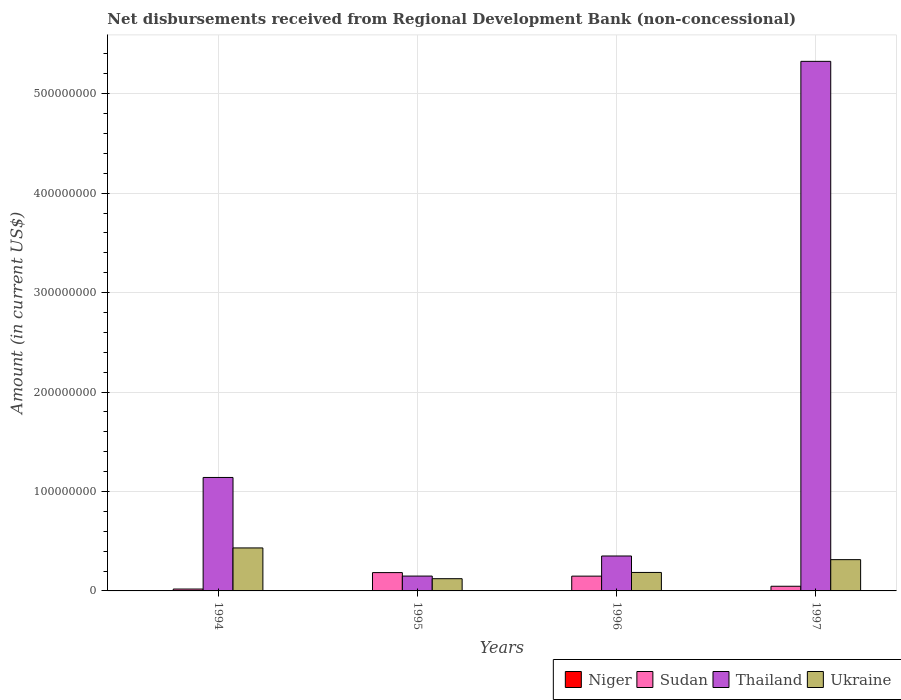How many different coloured bars are there?
Offer a very short reply. 3. Are the number of bars per tick equal to the number of legend labels?
Provide a succinct answer. No. Are the number of bars on each tick of the X-axis equal?
Offer a very short reply. Yes. In how many cases, is the number of bars for a given year not equal to the number of legend labels?
Your response must be concise. 4. What is the amount of disbursements received from Regional Development Bank in Sudan in 1995?
Provide a short and direct response. 1.84e+07. Across all years, what is the maximum amount of disbursements received from Regional Development Bank in Ukraine?
Your response must be concise. 4.32e+07. Across all years, what is the minimum amount of disbursements received from Regional Development Bank in Ukraine?
Provide a short and direct response. 1.23e+07. In which year was the amount of disbursements received from Regional Development Bank in Ukraine maximum?
Keep it short and to the point. 1994. What is the total amount of disbursements received from Regional Development Bank in Ukraine in the graph?
Offer a very short reply. 1.06e+08. What is the difference between the amount of disbursements received from Regional Development Bank in Thailand in 1995 and that in 1996?
Provide a succinct answer. -2.02e+07. What is the difference between the amount of disbursements received from Regional Development Bank in Sudan in 1996 and the amount of disbursements received from Regional Development Bank in Ukraine in 1994?
Make the answer very short. -2.84e+07. What is the average amount of disbursements received from Regional Development Bank in Sudan per year?
Ensure brevity in your answer.  9.97e+06. In the year 1997, what is the difference between the amount of disbursements received from Regional Development Bank in Sudan and amount of disbursements received from Regional Development Bank in Ukraine?
Provide a succinct answer. -2.68e+07. In how many years, is the amount of disbursements received from Regional Development Bank in Ukraine greater than 100000000 US$?
Your answer should be compact. 0. What is the ratio of the amount of disbursements received from Regional Development Bank in Sudan in 1994 to that in 1997?
Give a very brief answer. 0.4. Is the difference between the amount of disbursements received from Regional Development Bank in Sudan in 1995 and 1997 greater than the difference between the amount of disbursements received from Regional Development Bank in Ukraine in 1995 and 1997?
Your answer should be compact. Yes. What is the difference between the highest and the second highest amount of disbursements received from Regional Development Bank in Ukraine?
Your answer should be compact. 1.18e+07. What is the difference between the highest and the lowest amount of disbursements received from Regional Development Bank in Ukraine?
Offer a very short reply. 3.09e+07. How many bars are there?
Provide a short and direct response. 12. Are all the bars in the graph horizontal?
Offer a very short reply. No. What is the difference between two consecutive major ticks on the Y-axis?
Ensure brevity in your answer.  1.00e+08. Where does the legend appear in the graph?
Give a very brief answer. Bottom right. How many legend labels are there?
Provide a succinct answer. 4. How are the legend labels stacked?
Offer a terse response. Horizontal. What is the title of the graph?
Your answer should be very brief. Net disbursements received from Regional Development Bank (non-concessional). Does "Middle income" appear as one of the legend labels in the graph?
Give a very brief answer. No. What is the label or title of the X-axis?
Offer a very short reply. Years. What is the Amount (in current US$) of Sudan in 1994?
Provide a short and direct response. 1.89e+06. What is the Amount (in current US$) in Thailand in 1994?
Your answer should be compact. 1.14e+08. What is the Amount (in current US$) of Ukraine in 1994?
Offer a terse response. 4.32e+07. What is the Amount (in current US$) in Niger in 1995?
Your response must be concise. 0. What is the Amount (in current US$) in Sudan in 1995?
Ensure brevity in your answer.  1.84e+07. What is the Amount (in current US$) in Thailand in 1995?
Provide a short and direct response. 1.49e+07. What is the Amount (in current US$) in Ukraine in 1995?
Ensure brevity in your answer.  1.23e+07. What is the Amount (in current US$) in Sudan in 1996?
Give a very brief answer. 1.49e+07. What is the Amount (in current US$) in Thailand in 1996?
Give a very brief answer. 3.51e+07. What is the Amount (in current US$) in Ukraine in 1996?
Your answer should be compact. 1.86e+07. What is the Amount (in current US$) of Sudan in 1997?
Provide a succinct answer. 4.69e+06. What is the Amount (in current US$) in Thailand in 1997?
Keep it short and to the point. 5.33e+08. What is the Amount (in current US$) of Ukraine in 1997?
Your answer should be very brief. 3.15e+07. Across all years, what is the maximum Amount (in current US$) in Sudan?
Provide a succinct answer. 1.84e+07. Across all years, what is the maximum Amount (in current US$) of Thailand?
Keep it short and to the point. 5.33e+08. Across all years, what is the maximum Amount (in current US$) in Ukraine?
Your response must be concise. 4.32e+07. Across all years, what is the minimum Amount (in current US$) of Sudan?
Ensure brevity in your answer.  1.89e+06. Across all years, what is the minimum Amount (in current US$) in Thailand?
Offer a terse response. 1.49e+07. Across all years, what is the minimum Amount (in current US$) of Ukraine?
Provide a succinct answer. 1.23e+07. What is the total Amount (in current US$) in Sudan in the graph?
Keep it short and to the point. 3.99e+07. What is the total Amount (in current US$) in Thailand in the graph?
Your response must be concise. 6.97e+08. What is the total Amount (in current US$) in Ukraine in the graph?
Keep it short and to the point. 1.06e+08. What is the difference between the Amount (in current US$) in Sudan in 1994 and that in 1995?
Your answer should be compact. -1.65e+07. What is the difference between the Amount (in current US$) in Thailand in 1994 and that in 1995?
Your answer should be very brief. 9.92e+07. What is the difference between the Amount (in current US$) in Ukraine in 1994 and that in 1995?
Provide a succinct answer. 3.09e+07. What is the difference between the Amount (in current US$) of Sudan in 1994 and that in 1996?
Make the answer very short. -1.30e+07. What is the difference between the Amount (in current US$) in Thailand in 1994 and that in 1996?
Make the answer very short. 7.90e+07. What is the difference between the Amount (in current US$) in Ukraine in 1994 and that in 1996?
Your answer should be compact. 2.47e+07. What is the difference between the Amount (in current US$) in Sudan in 1994 and that in 1997?
Your answer should be compact. -2.80e+06. What is the difference between the Amount (in current US$) in Thailand in 1994 and that in 1997?
Provide a succinct answer. -4.18e+08. What is the difference between the Amount (in current US$) in Ukraine in 1994 and that in 1997?
Keep it short and to the point. 1.18e+07. What is the difference between the Amount (in current US$) of Sudan in 1995 and that in 1996?
Your answer should be compact. 3.55e+06. What is the difference between the Amount (in current US$) of Thailand in 1995 and that in 1996?
Give a very brief answer. -2.02e+07. What is the difference between the Amount (in current US$) in Ukraine in 1995 and that in 1996?
Your answer should be very brief. -6.29e+06. What is the difference between the Amount (in current US$) in Sudan in 1995 and that in 1997?
Offer a terse response. 1.37e+07. What is the difference between the Amount (in current US$) of Thailand in 1995 and that in 1997?
Provide a short and direct response. -5.18e+08. What is the difference between the Amount (in current US$) of Ukraine in 1995 and that in 1997?
Provide a succinct answer. -1.92e+07. What is the difference between the Amount (in current US$) in Sudan in 1996 and that in 1997?
Your answer should be very brief. 1.02e+07. What is the difference between the Amount (in current US$) of Thailand in 1996 and that in 1997?
Offer a terse response. -4.97e+08. What is the difference between the Amount (in current US$) in Ukraine in 1996 and that in 1997?
Your answer should be very brief. -1.29e+07. What is the difference between the Amount (in current US$) of Sudan in 1994 and the Amount (in current US$) of Thailand in 1995?
Provide a succinct answer. -1.30e+07. What is the difference between the Amount (in current US$) of Sudan in 1994 and the Amount (in current US$) of Ukraine in 1995?
Give a very brief answer. -1.04e+07. What is the difference between the Amount (in current US$) in Thailand in 1994 and the Amount (in current US$) in Ukraine in 1995?
Keep it short and to the point. 1.02e+08. What is the difference between the Amount (in current US$) in Sudan in 1994 and the Amount (in current US$) in Thailand in 1996?
Keep it short and to the point. -3.32e+07. What is the difference between the Amount (in current US$) in Sudan in 1994 and the Amount (in current US$) in Ukraine in 1996?
Provide a succinct answer. -1.67e+07. What is the difference between the Amount (in current US$) in Thailand in 1994 and the Amount (in current US$) in Ukraine in 1996?
Your answer should be compact. 9.55e+07. What is the difference between the Amount (in current US$) of Sudan in 1994 and the Amount (in current US$) of Thailand in 1997?
Provide a short and direct response. -5.31e+08. What is the difference between the Amount (in current US$) in Sudan in 1994 and the Amount (in current US$) in Ukraine in 1997?
Offer a very short reply. -2.96e+07. What is the difference between the Amount (in current US$) of Thailand in 1994 and the Amount (in current US$) of Ukraine in 1997?
Give a very brief answer. 8.27e+07. What is the difference between the Amount (in current US$) in Sudan in 1995 and the Amount (in current US$) in Thailand in 1996?
Offer a terse response. -1.67e+07. What is the difference between the Amount (in current US$) in Sudan in 1995 and the Amount (in current US$) in Ukraine in 1996?
Offer a very short reply. -1.56e+05. What is the difference between the Amount (in current US$) of Thailand in 1995 and the Amount (in current US$) of Ukraine in 1996?
Ensure brevity in your answer.  -3.66e+06. What is the difference between the Amount (in current US$) in Sudan in 1995 and the Amount (in current US$) in Thailand in 1997?
Offer a terse response. -5.14e+08. What is the difference between the Amount (in current US$) in Sudan in 1995 and the Amount (in current US$) in Ukraine in 1997?
Offer a terse response. -1.30e+07. What is the difference between the Amount (in current US$) of Thailand in 1995 and the Amount (in current US$) of Ukraine in 1997?
Provide a succinct answer. -1.65e+07. What is the difference between the Amount (in current US$) in Sudan in 1996 and the Amount (in current US$) in Thailand in 1997?
Your answer should be compact. -5.18e+08. What is the difference between the Amount (in current US$) in Sudan in 1996 and the Amount (in current US$) in Ukraine in 1997?
Keep it short and to the point. -1.66e+07. What is the difference between the Amount (in current US$) of Thailand in 1996 and the Amount (in current US$) of Ukraine in 1997?
Keep it short and to the point. 3.67e+06. What is the average Amount (in current US$) of Sudan per year?
Provide a short and direct response. 9.97e+06. What is the average Amount (in current US$) of Thailand per year?
Offer a very short reply. 1.74e+08. What is the average Amount (in current US$) of Ukraine per year?
Your response must be concise. 2.64e+07. In the year 1994, what is the difference between the Amount (in current US$) of Sudan and Amount (in current US$) of Thailand?
Keep it short and to the point. -1.12e+08. In the year 1994, what is the difference between the Amount (in current US$) in Sudan and Amount (in current US$) in Ukraine?
Offer a terse response. -4.13e+07. In the year 1994, what is the difference between the Amount (in current US$) in Thailand and Amount (in current US$) in Ukraine?
Offer a very short reply. 7.09e+07. In the year 1995, what is the difference between the Amount (in current US$) of Sudan and Amount (in current US$) of Thailand?
Offer a terse response. 3.50e+06. In the year 1995, what is the difference between the Amount (in current US$) of Sudan and Amount (in current US$) of Ukraine?
Make the answer very short. 6.14e+06. In the year 1995, what is the difference between the Amount (in current US$) of Thailand and Amount (in current US$) of Ukraine?
Your answer should be very brief. 2.64e+06. In the year 1996, what is the difference between the Amount (in current US$) of Sudan and Amount (in current US$) of Thailand?
Offer a very short reply. -2.02e+07. In the year 1996, what is the difference between the Amount (in current US$) in Sudan and Amount (in current US$) in Ukraine?
Keep it short and to the point. -3.71e+06. In the year 1996, what is the difference between the Amount (in current US$) of Thailand and Amount (in current US$) of Ukraine?
Your response must be concise. 1.65e+07. In the year 1997, what is the difference between the Amount (in current US$) of Sudan and Amount (in current US$) of Thailand?
Give a very brief answer. -5.28e+08. In the year 1997, what is the difference between the Amount (in current US$) in Sudan and Amount (in current US$) in Ukraine?
Your answer should be compact. -2.68e+07. In the year 1997, what is the difference between the Amount (in current US$) of Thailand and Amount (in current US$) of Ukraine?
Your response must be concise. 5.01e+08. What is the ratio of the Amount (in current US$) in Sudan in 1994 to that in 1995?
Offer a terse response. 0.1. What is the ratio of the Amount (in current US$) in Thailand in 1994 to that in 1995?
Ensure brevity in your answer.  7.64. What is the ratio of the Amount (in current US$) of Ukraine in 1994 to that in 1995?
Offer a very short reply. 3.52. What is the ratio of the Amount (in current US$) of Sudan in 1994 to that in 1996?
Keep it short and to the point. 0.13. What is the ratio of the Amount (in current US$) in Thailand in 1994 to that in 1996?
Your response must be concise. 3.25. What is the ratio of the Amount (in current US$) of Ukraine in 1994 to that in 1996?
Your answer should be compact. 2.33. What is the ratio of the Amount (in current US$) of Sudan in 1994 to that in 1997?
Offer a very short reply. 0.4. What is the ratio of the Amount (in current US$) in Thailand in 1994 to that in 1997?
Provide a succinct answer. 0.21. What is the ratio of the Amount (in current US$) of Ukraine in 1994 to that in 1997?
Make the answer very short. 1.37. What is the ratio of the Amount (in current US$) in Sudan in 1995 to that in 1996?
Your answer should be very brief. 1.24. What is the ratio of the Amount (in current US$) of Thailand in 1995 to that in 1996?
Your answer should be compact. 0.43. What is the ratio of the Amount (in current US$) in Ukraine in 1995 to that in 1996?
Keep it short and to the point. 0.66. What is the ratio of the Amount (in current US$) of Sudan in 1995 to that in 1997?
Ensure brevity in your answer.  3.93. What is the ratio of the Amount (in current US$) in Thailand in 1995 to that in 1997?
Give a very brief answer. 0.03. What is the ratio of the Amount (in current US$) in Ukraine in 1995 to that in 1997?
Your response must be concise. 0.39. What is the ratio of the Amount (in current US$) in Sudan in 1996 to that in 1997?
Ensure brevity in your answer.  3.17. What is the ratio of the Amount (in current US$) of Thailand in 1996 to that in 1997?
Provide a succinct answer. 0.07. What is the ratio of the Amount (in current US$) of Ukraine in 1996 to that in 1997?
Offer a terse response. 0.59. What is the difference between the highest and the second highest Amount (in current US$) in Sudan?
Make the answer very short. 3.55e+06. What is the difference between the highest and the second highest Amount (in current US$) of Thailand?
Offer a terse response. 4.18e+08. What is the difference between the highest and the second highest Amount (in current US$) in Ukraine?
Your answer should be very brief. 1.18e+07. What is the difference between the highest and the lowest Amount (in current US$) of Sudan?
Offer a very short reply. 1.65e+07. What is the difference between the highest and the lowest Amount (in current US$) in Thailand?
Give a very brief answer. 5.18e+08. What is the difference between the highest and the lowest Amount (in current US$) in Ukraine?
Your response must be concise. 3.09e+07. 